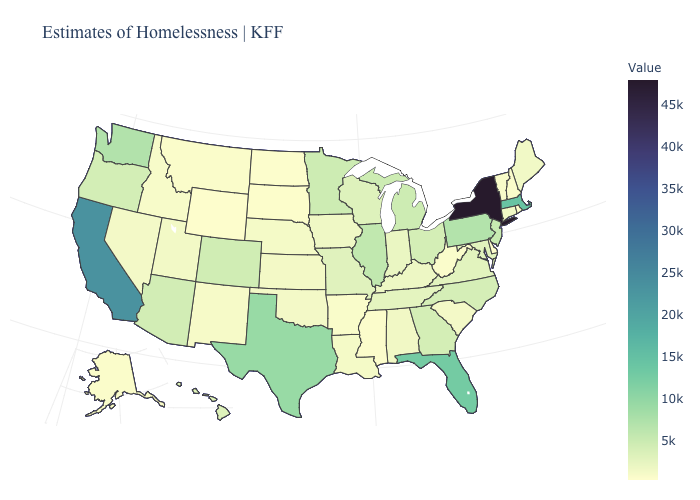Among the states that border Colorado , does Arizona have the highest value?
Concise answer only. Yes. Which states have the lowest value in the MidWest?
Quick response, please. North Dakota. Does New Hampshire have the lowest value in the USA?
Concise answer only. No. 